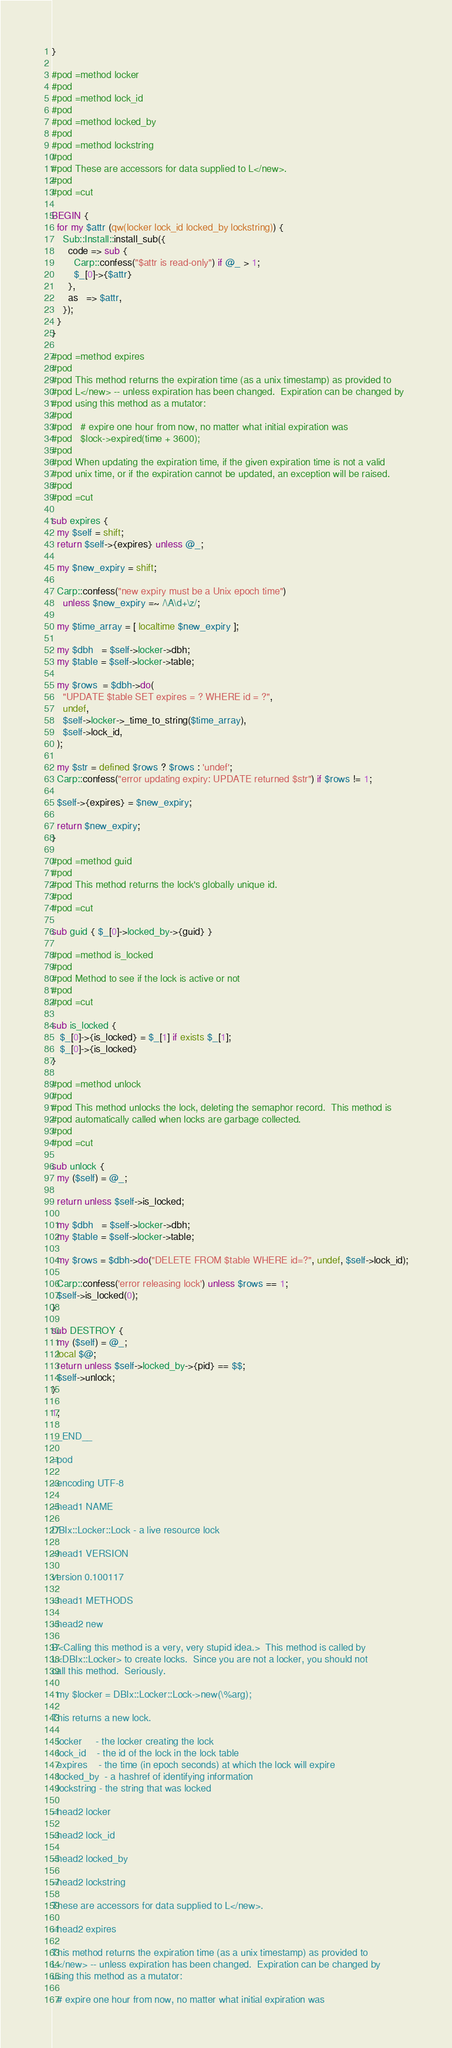Convert code to text. <code><loc_0><loc_0><loc_500><loc_500><_Perl_>}

#pod =method locker
#pod
#pod =method lock_id
#pod
#pod =method locked_by
#pod
#pod =method lockstring
#pod
#pod These are accessors for data supplied to L</new>.
#pod
#pod =cut

BEGIN {
  for my $attr (qw(locker lock_id locked_by lockstring)) {
    Sub::Install::install_sub({
      code => sub {
        Carp::confess("$attr is read-only") if @_ > 1;
        $_[0]->{$attr}
      },
      as   => $attr,
    });
  }
}

#pod =method expires
#pod
#pod This method returns the expiration time (as a unix timestamp) as provided to
#pod L</new> -- unless expiration has been changed.  Expiration can be changed by
#pod using this method as a mutator:
#pod
#pod   # expire one hour from now, no matter what initial expiration was
#pod   $lock->expired(time + 3600);
#pod
#pod When updating the expiration time, if the given expiration time is not a valid
#pod unix time, or if the expiration cannot be updated, an exception will be raised.
#pod
#pod =cut

sub expires {
  my $self = shift;
  return $self->{expires} unless @_;

  my $new_expiry = shift;

  Carp::confess("new expiry must be a Unix epoch time")
    unless $new_expiry =~ /\A\d+\z/;

  my $time_array = [ localtime $new_expiry ];

  my $dbh   = $self->locker->dbh;
  my $table = $self->locker->table;

  my $rows  = $dbh->do(
    "UPDATE $table SET expires = ? WHERE id = ?",
    undef,
    $self->locker->_time_to_string($time_array),
    $self->lock_id,
  );

  my $str = defined $rows ? $rows : 'undef';
  Carp::confess("error updating expiry: UPDATE returned $str") if $rows != 1;

  $self->{expires} = $new_expiry;

  return $new_expiry;
}

#pod =method guid
#pod
#pod This method returns the lock's globally unique id.
#pod
#pod =cut

sub guid { $_[0]->locked_by->{guid} }

#pod =method is_locked
#pod
#pod Method to see if the lock is active or not
#pod
#pod =cut

sub is_locked {
   $_[0]->{is_locked} = $_[1] if exists $_[1];
   $_[0]->{is_locked}
}

#pod =method unlock
#pod
#pod This method unlocks the lock, deleting the semaphor record.  This method is
#pod automatically called when locks are garbage collected.
#pod
#pod =cut

sub unlock {
  my ($self) = @_;

  return unless $self->is_locked;

  my $dbh   = $self->locker->dbh;
  my $table = $self->locker->table;

  my $rows = $dbh->do("DELETE FROM $table WHERE id=?", undef, $self->lock_id);

  Carp::confess('error releasing lock') unless $rows == 1;
  $self->is_locked(0);
}

sub DESTROY {
  my ($self) = @_;
  local $@;
  return unless $self->locked_by->{pid} == $$;
  $self->unlock;
}

1;

__END__

=pod

=encoding UTF-8

=head1 NAME

DBIx::Locker::Lock - a live resource lock

=head1 VERSION

version 0.100117

=head1 METHODS

=head2 new

B<Calling this method is a very, very stupid idea.>  This method is called by
L<DBIx::Locker> to create locks.  Since you are not a locker, you should not
call this method.  Seriously.

  my $locker = DBIx::Locker::Lock->new(\%arg);

This returns a new lock. 

  locker     - the locker creating the lock
  lock_id    - the id of the lock in the lock table
  expires    - the time (in epoch seconds) at which the lock will expire
  locked_by  - a hashref of identifying information
  lockstring - the string that was locked

=head2 locker

=head2 lock_id

=head2 locked_by

=head2 lockstring

These are accessors for data supplied to L</new>.

=head2 expires

This method returns the expiration time (as a unix timestamp) as provided to
L</new> -- unless expiration has been changed.  Expiration can be changed by
using this method as a mutator:

  # expire one hour from now, no matter what initial expiration was</code> 